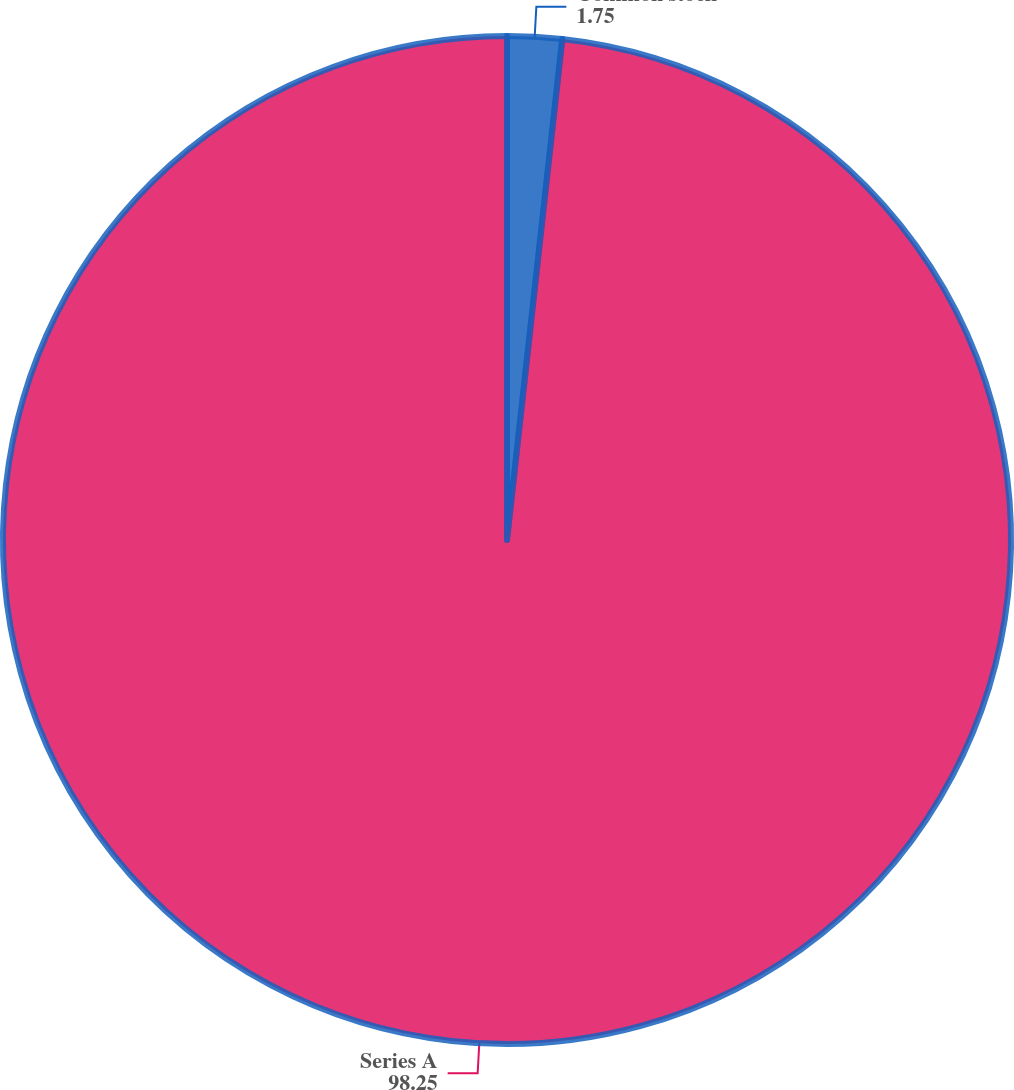Convert chart. <chart><loc_0><loc_0><loc_500><loc_500><pie_chart><fcel>Common stock<fcel>Series A<nl><fcel>1.75%<fcel>98.25%<nl></chart> 